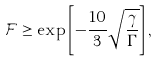<formula> <loc_0><loc_0><loc_500><loc_500>\mathcal { F } \geq \exp \left [ - \frac { 1 0 } { 3 } \sqrt { \frac { \gamma } { \Gamma } } \right ] ,</formula> 